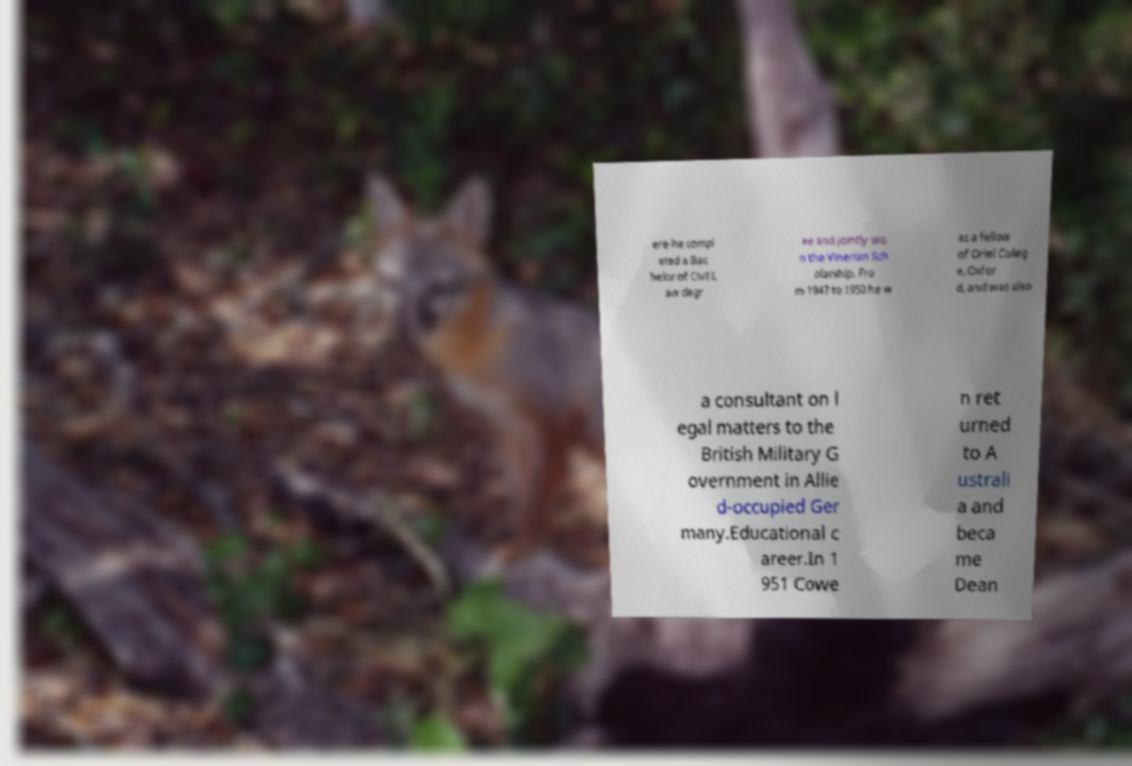Could you assist in decoding the text presented in this image and type it out clearly? ere he compl eted a Bac helor of Civil L aw degr ee and jointly wo n the Vinerian Sch olarship. Fro m 1947 to 1950 he w as a fellow of Oriel Colleg e, Oxfor d, and was also a consultant on l egal matters to the British Military G overnment in Allie d-occupied Ger many.Educational c areer.In 1 951 Cowe n ret urned to A ustrali a and beca me Dean 